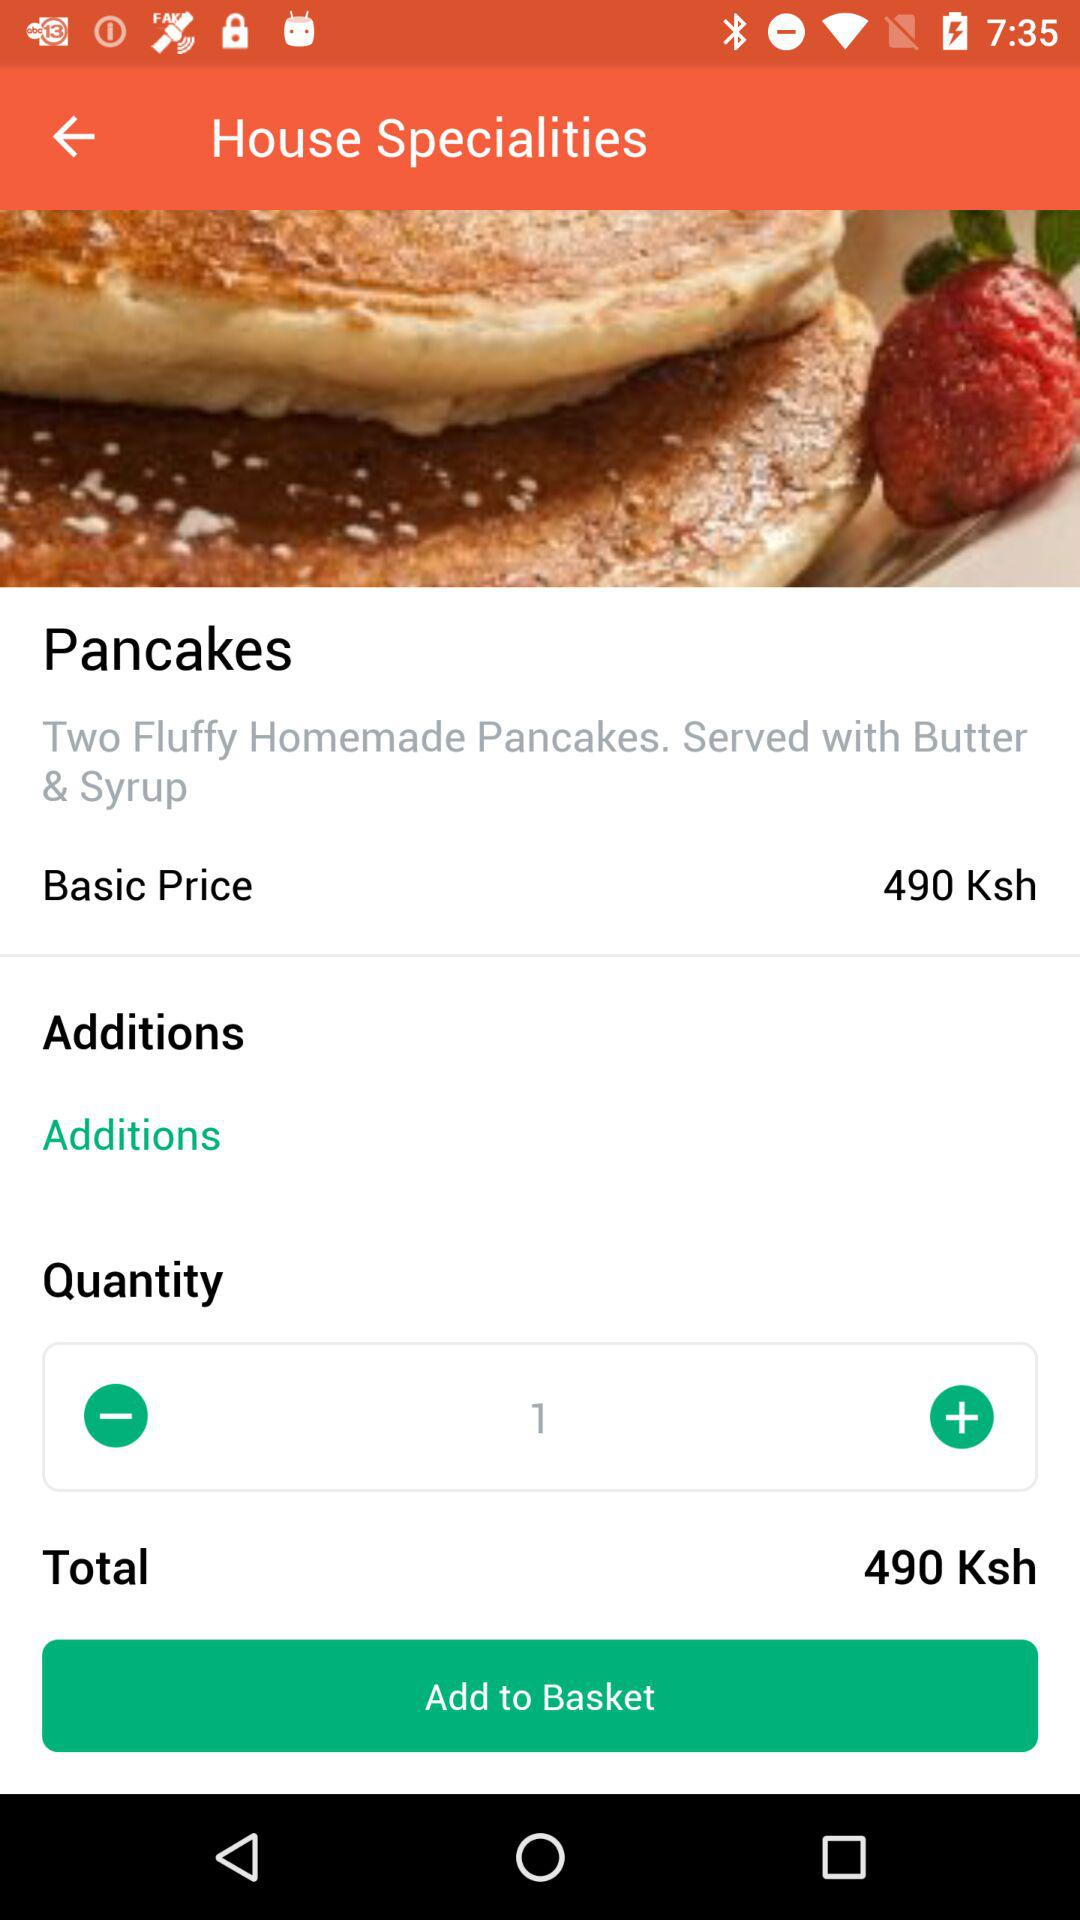What is the quantity? The quantity is 1. 